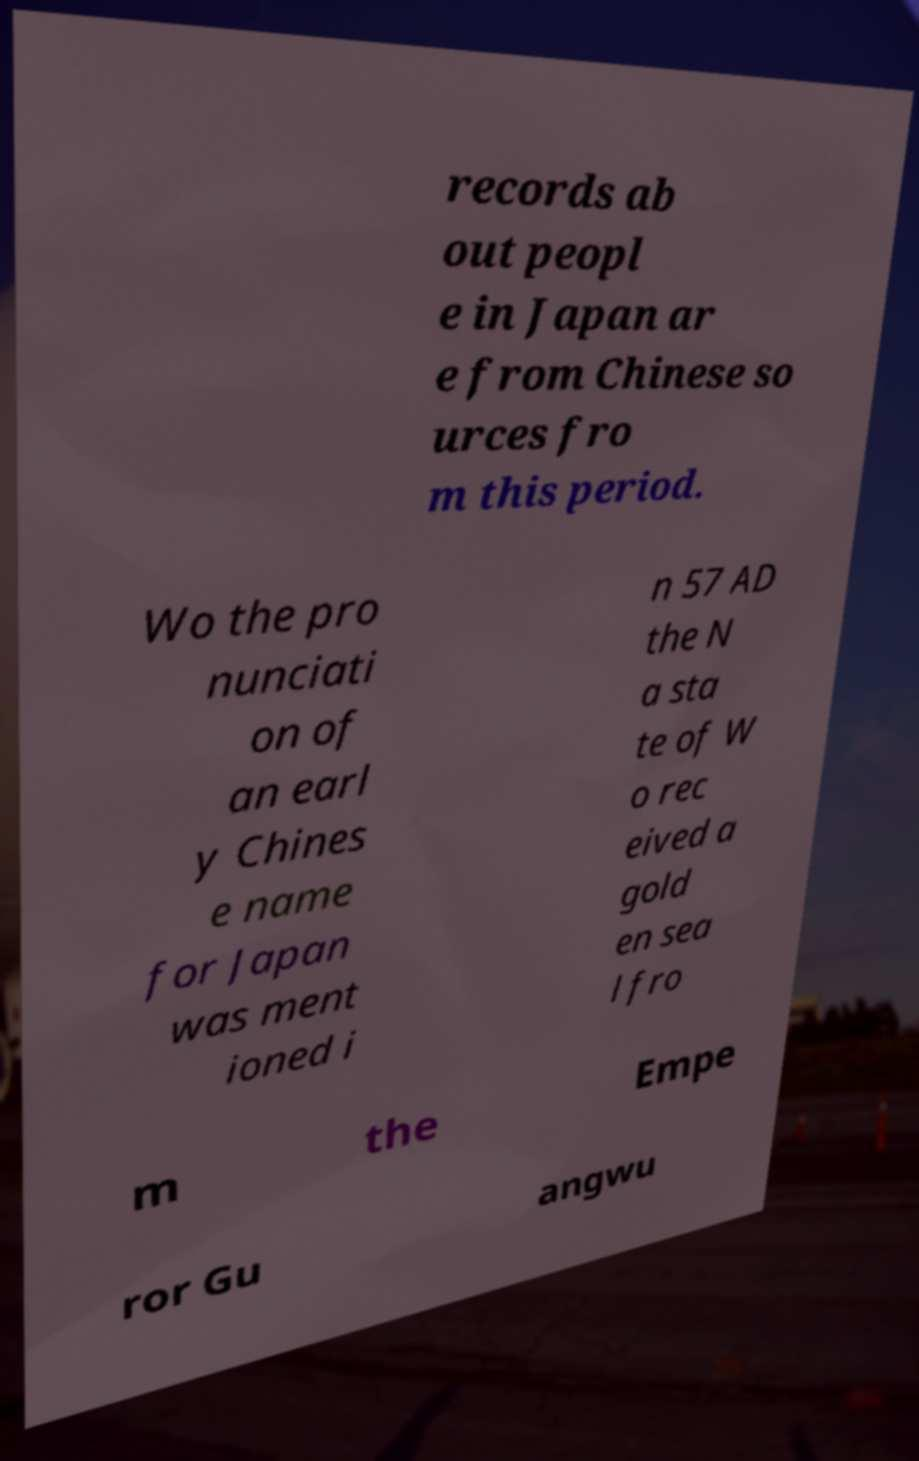What messages or text are displayed in this image? I need them in a readable, typed format. records ab out peopl e in Japan ar e from Chinese so urces fro m this period. Wo the pro nunciati on of an earl y Chines e name for Japan was ment ioned i n 57 AD the N a sta te of W o rec eived a gold en sea l fro m the Empe ror Gu angwu 